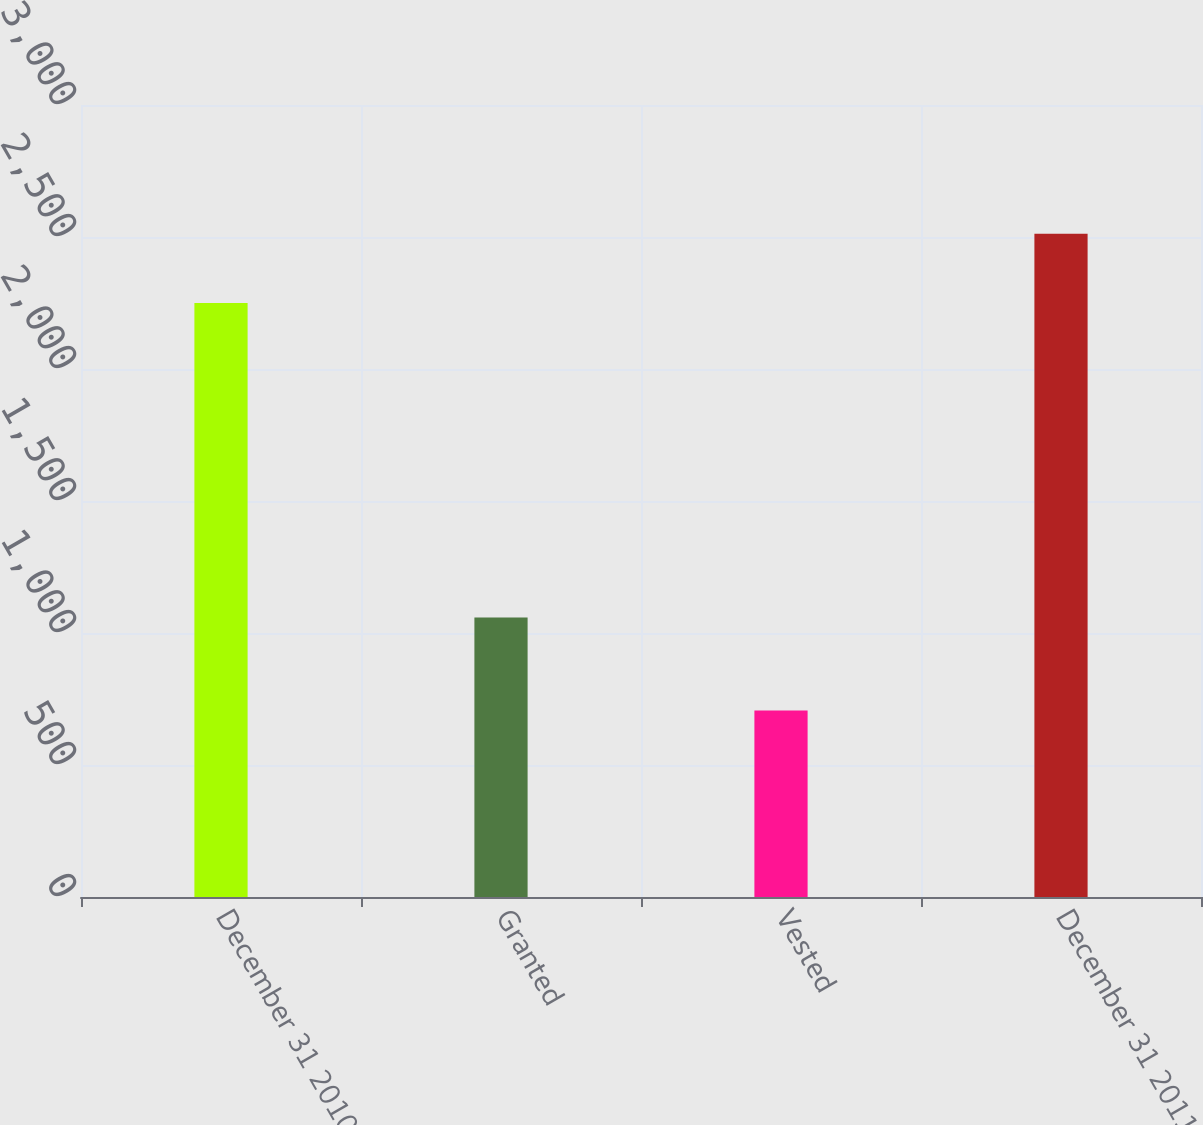Convert chart to OTSL. <chart><loc_0><loc_0><loc_500><loc_500><bar_chart><fcel>December 31 2010<fcel>Granted<fcel>Vested<fcel>December 31 2011<nl><fcel>2250<fcel>1059<fcel>706<fcel>2512<nl></chart> 